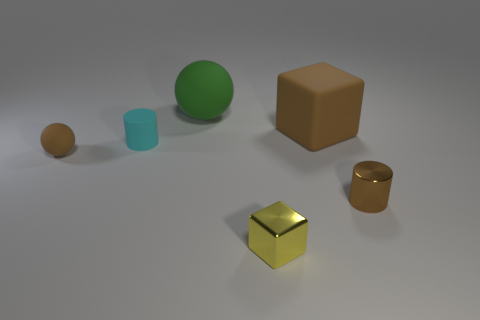Does the rubber cube have the same size as the green ball?
Ensure brevity in your answer.  Yes. What number of things are either small rubber objects that are to the right of the small brown matte ball or small cubes?
Your answer should be compact. 2. There is a tiny matte object that is behind the tiny brown object that is to the left of the yellow shiny thing; what is its shape?
Your answer should be compact. Cylinder. There is a green rubber ball; does it have the same size as the metal thing that is on the right side of the rubber block?
Make the answer very short. No. What is the cylinder that is left of the big green thing made of?
Make the answer very short. Rubber. What number of tiny things are on the right side of the yellow metallic object and to the left of the cyan cylinder?
Your answer should be very brief. 0. There is a brown block that is the same size as the green object; what is its material?
Provide a succinct answer. Rubber. There is a cube to the left of the brown cube; does it have the same size as the cylinder that is left of the small shiny cylinder?
Ensure brevity in your answer.  Yes. Are there any balls behind the tiny cyan matte thing?
Your answer should be very brief. Yes. There is a sphere behind the small brown thing that is on the left side of the large cube; what color is it?
Your answer should be very brief. Green. 